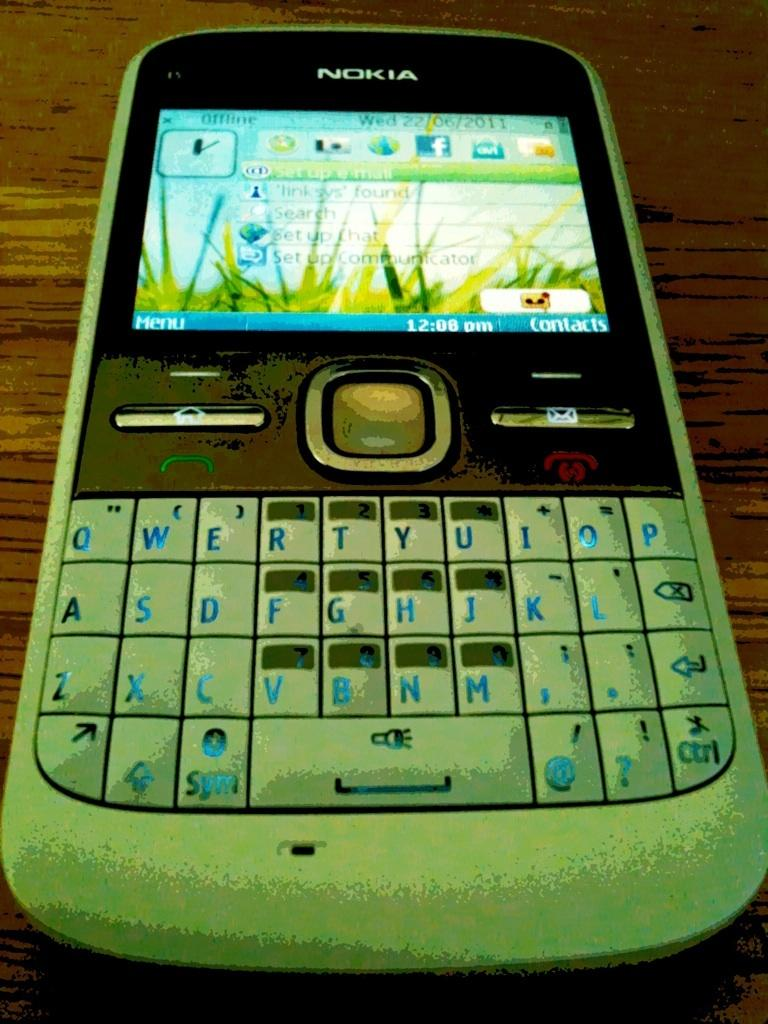<image>
Share a concise interpretation of the image provided. A Nokia phone is shown with greenery on the screen. 